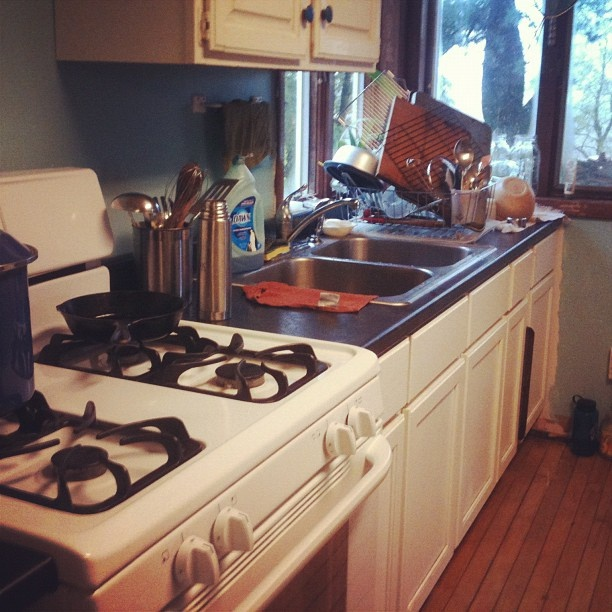Describe the objects in this image and their specific colors. I can see oven in black, tan, and brown tones, sink in black and gray tones, bottle in black, darkgray, gray, and blue tones, bottle in black, gray, maroon, and brown tones, and bowl in black, ivory, navy, and darkgray tones in this image. 